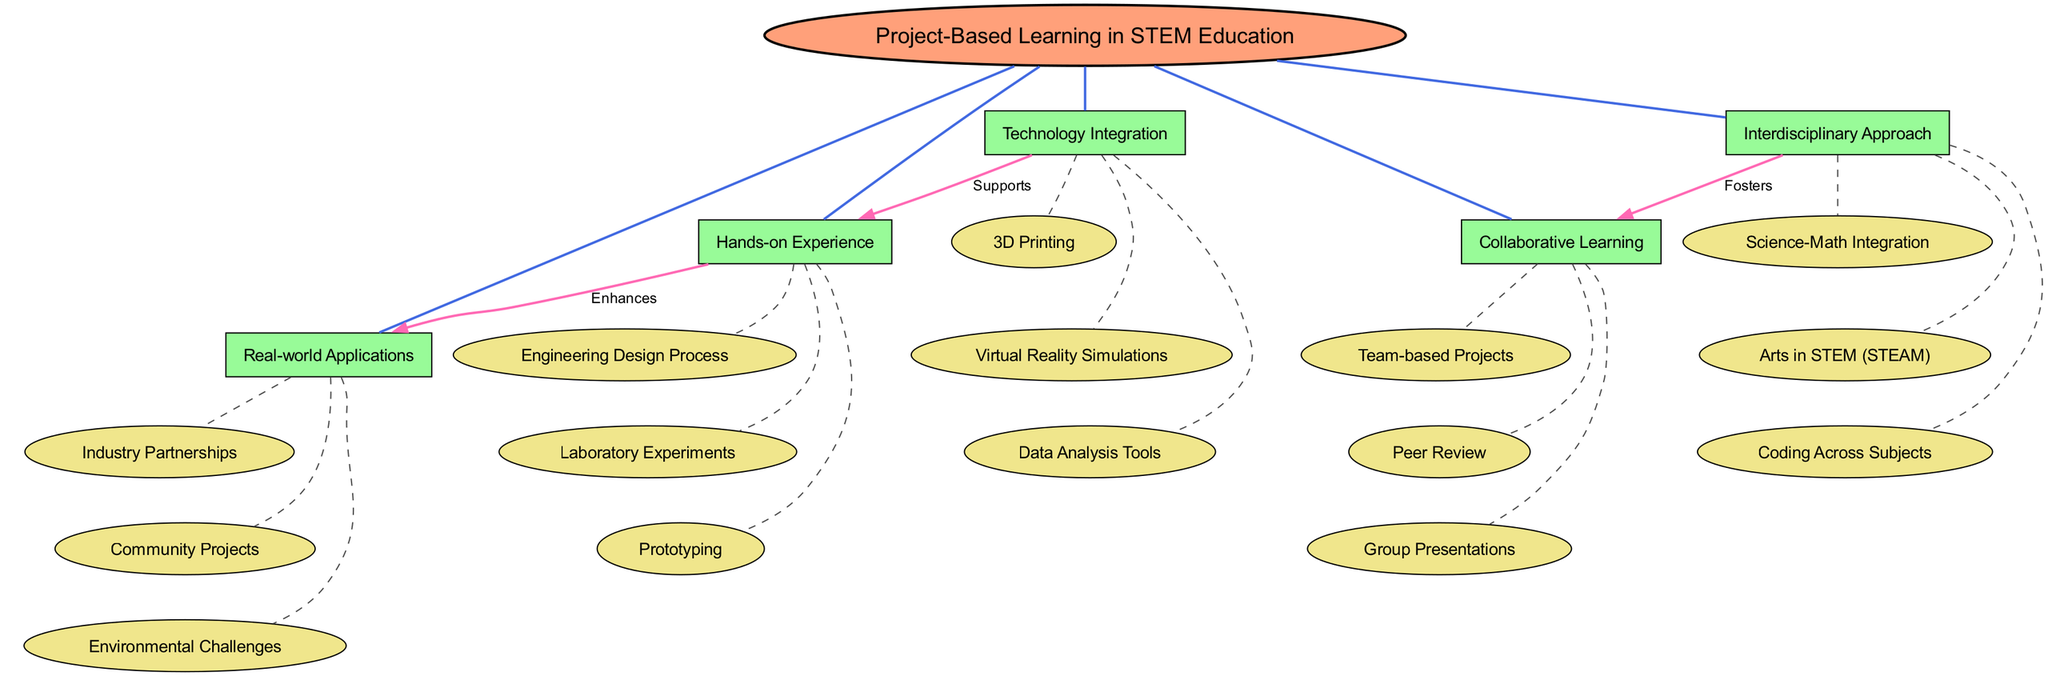What is the central concept of the diagram? The central concept is explicitly labeled in the diagram as "Project-Based Learning in STEM Education." It is connected to all the main nodes, making it clear that it is the primary focus of the concept map.
Answer: Project-Based Learning in STEM Education How many main nodes are present in the diagram? The diagram lists five main nodes under the central concept, showing five distinct strategies for project-based learning in STEM education.
Answer: 5 What enhances the connection between Hands-on Experience and Real-world Applications? The diagram specifies that "Hands-on Experience" is connected to "Real-world Applications" with the label "Enhances," indicating that hands-on experience contributes positively to real-world applications in the learning process.
Answer: Enhances Which main node fosters Collaborative Learning? Looking at the connections in the diagram, "Interdisciplinary Approach" is explicitly connected to "Collaborative Learning" labeled with "Fosters," indicating its role in promoting collaborative learning.
Answer: Interdisciplinary Approach What type of projects are included under Collaborative Learning? The diagram lists three sub-nodes under "Collaborative Learning," one of which is "Team-based Projects," which directly mentions the specific type of projects that are part of this learning strategy.
Answer: Team-based Projects Which technology is mentioned as supporting Hands-on Experience? The diagram highlights "Technology Integration" which includes "3D Printing," among other sub-nodes. The connection "Supports" indicates that technology like 3D printing aids hands-on experiences.
Answer: 3D Printing How many sub-nodes are related to Real-world Applications? The diagram shows three distinct sub-nodes beneath "Real-world Applications," each representing different aspects of applying learning in real-world settings.
Answer: 3 What is the relationship between the Interdisciplinary Approach and Technology Integration? The diagram does not directly depict a connection between "Interdisciplinary Approach" and "Technology Integration," demonstrating that while they are main nodes, they do not have a specified relationship or interaction in this concept map.
Answer: None What do the sub-nodes under Hands-on Experience represent? The sub-nodes under "Hands-on Experience" include "Engineering Design Process," "Laboratory Experiments," and "Prototyping," which collectively represent practical aspects of learning through direct engagement in STEM activities.
Answer: Engineering Design Process, Laboratory Experiments, Prototyping 